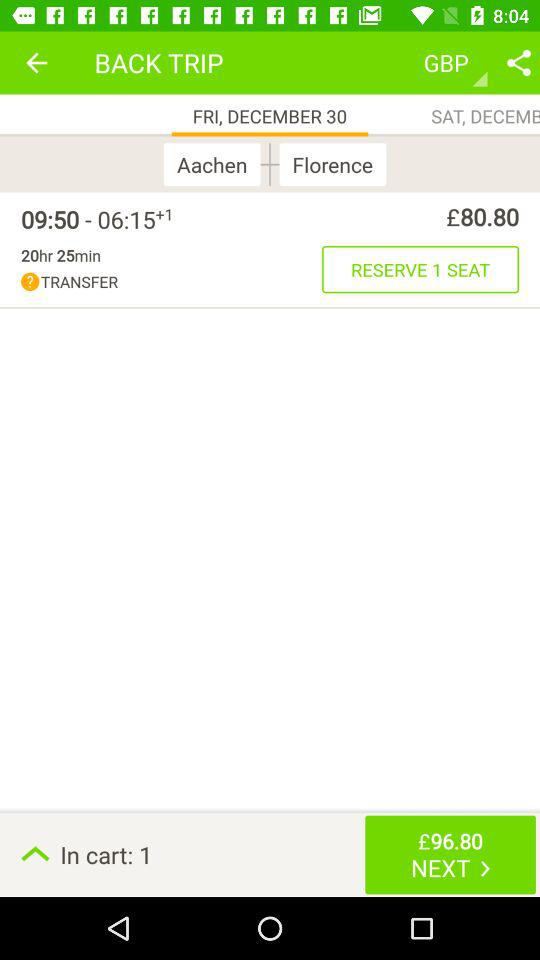How much is the total price of the trip?
Answer the question using a single word or phrase. £96.80 